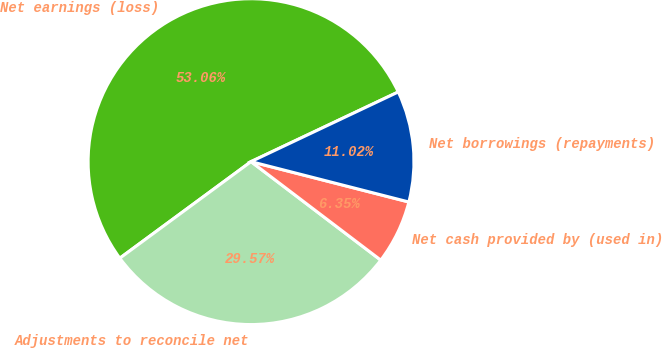<chart> <loc_0><loc_0><loc_500><loc_500><pie_chart><fcel>Net earnings (loss)<fcel>Adjustments to reconcile net<fcel>Net cash provided by (used in)<fcel>Net borrowings (repayments)<nl><fcel>53.06%<fcel>29.57%<fcel>6.35%<fcel>11.02%<nl></chart> 